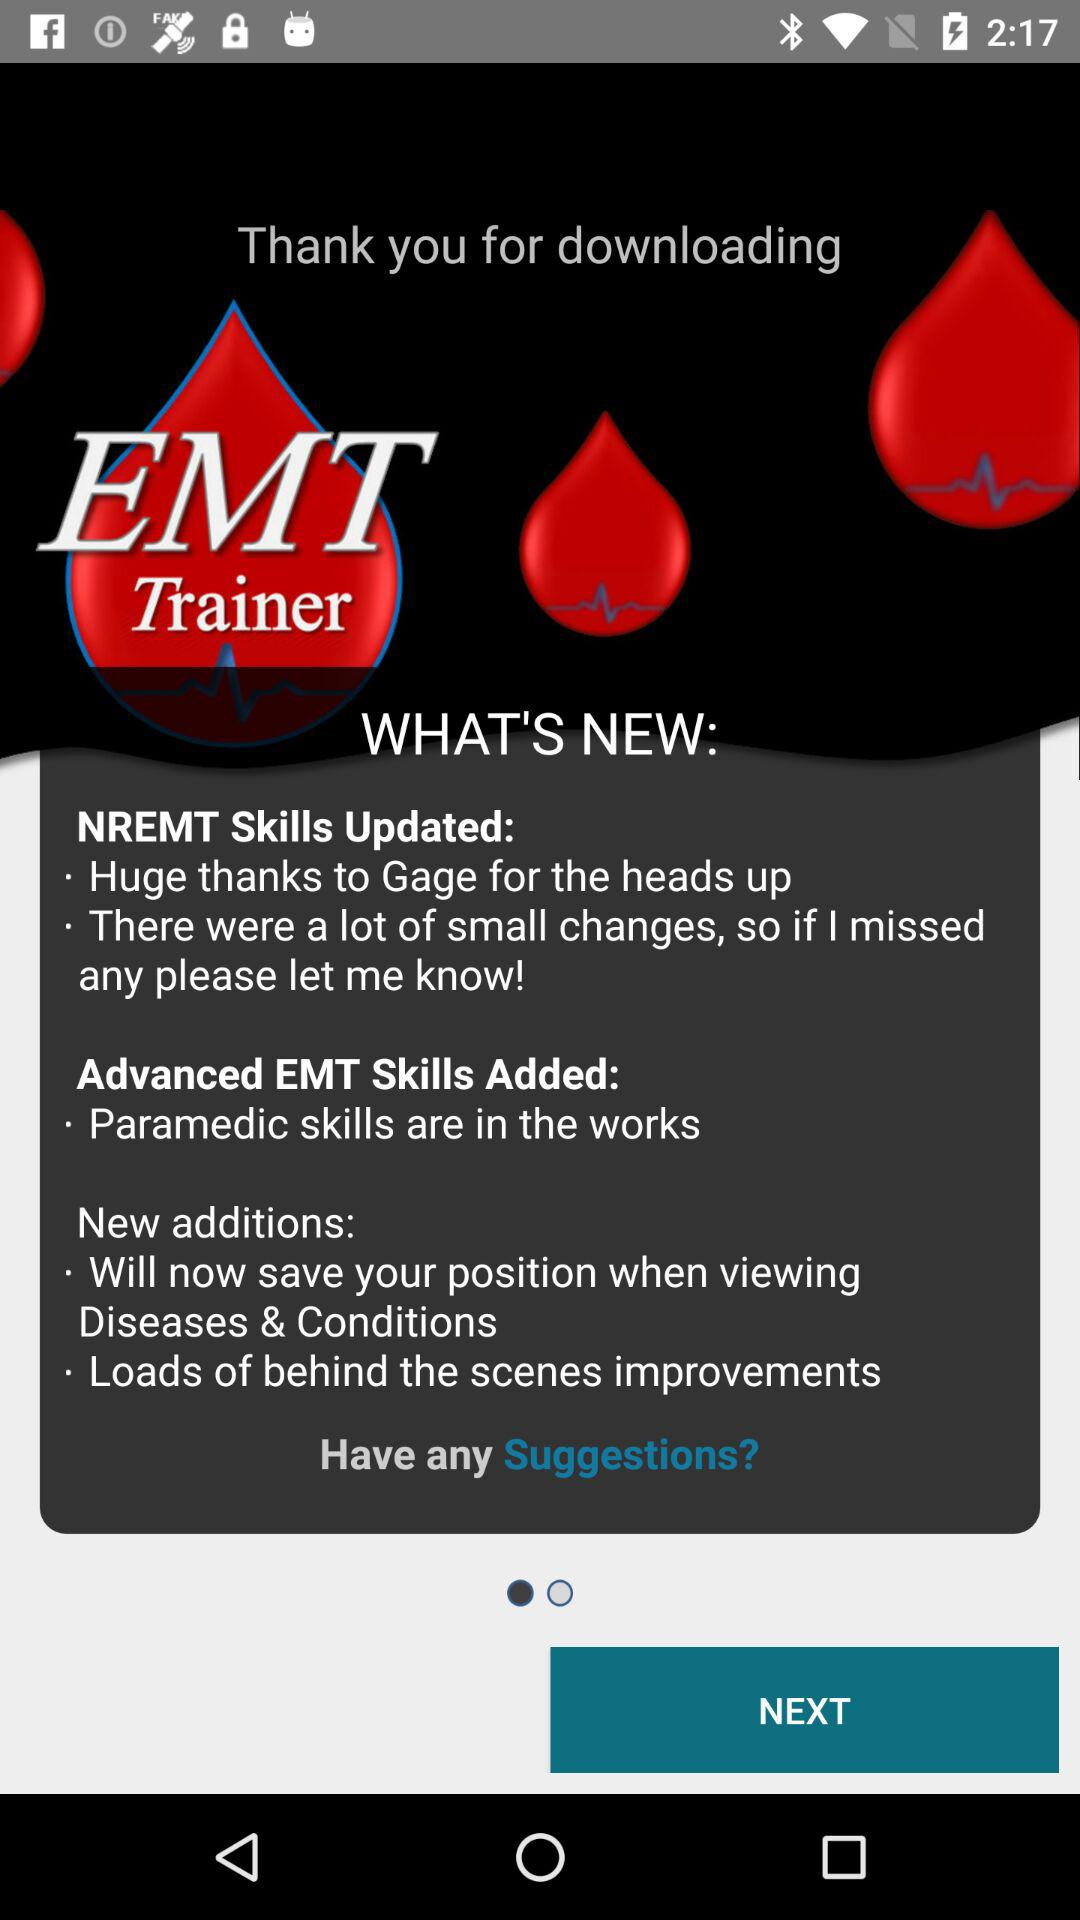Who downloaded "EMT Trainer"?
When the provided information is insufficient, respond with <no answer>. <no answer> 